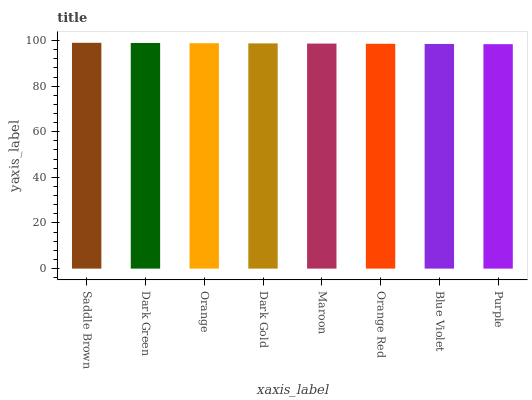Is Purple the minimum?
Answer yes or no. Yes. Is Saddle Brown the maximum?
Answer yes or no. Yes. Is Dark Green the minimum?
Answer yes or no. No. Is Dark Green the maximum?
Answer yes or no. No. Is Saddle Brown greater than Dark Green?
Answer yes or no. Yes. Is Dark Green less than Saddle Brown?
Answer yes or no. Yes. Is Dark Green greater than Saddle Brown?
Answer yes or no. No. Is Saddle Brown less than Dark Green?
Answer yes or no. No. Is Dark Gold the high median?
Answer yes or no. Yes. Is Maroon the low median?
Answer yes or no. Yes. Is Blue Violet the high median?
Answer yes or no. No. Is Saddle Brown the low median?
Answer yes or no. No. 